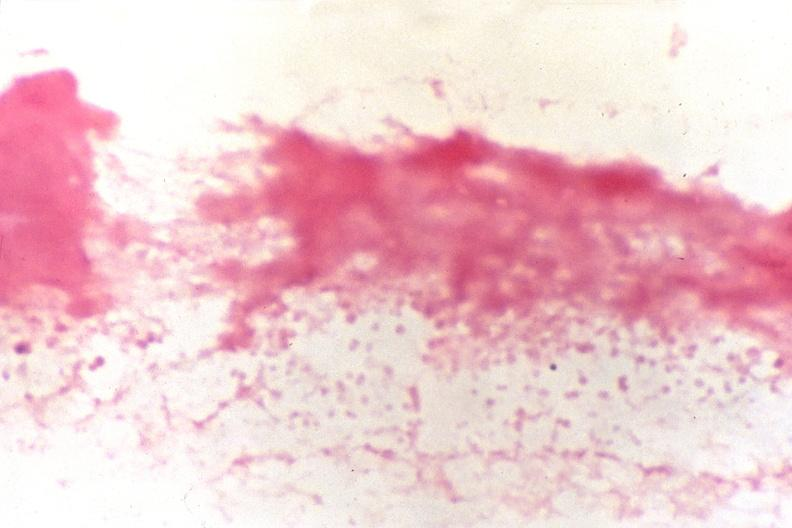does this image show cerebrospinal fluid, smear showing gram negative cocci, neisseria meningitidis, gram stain?
Answer the question using a single word or phrase. Yes 